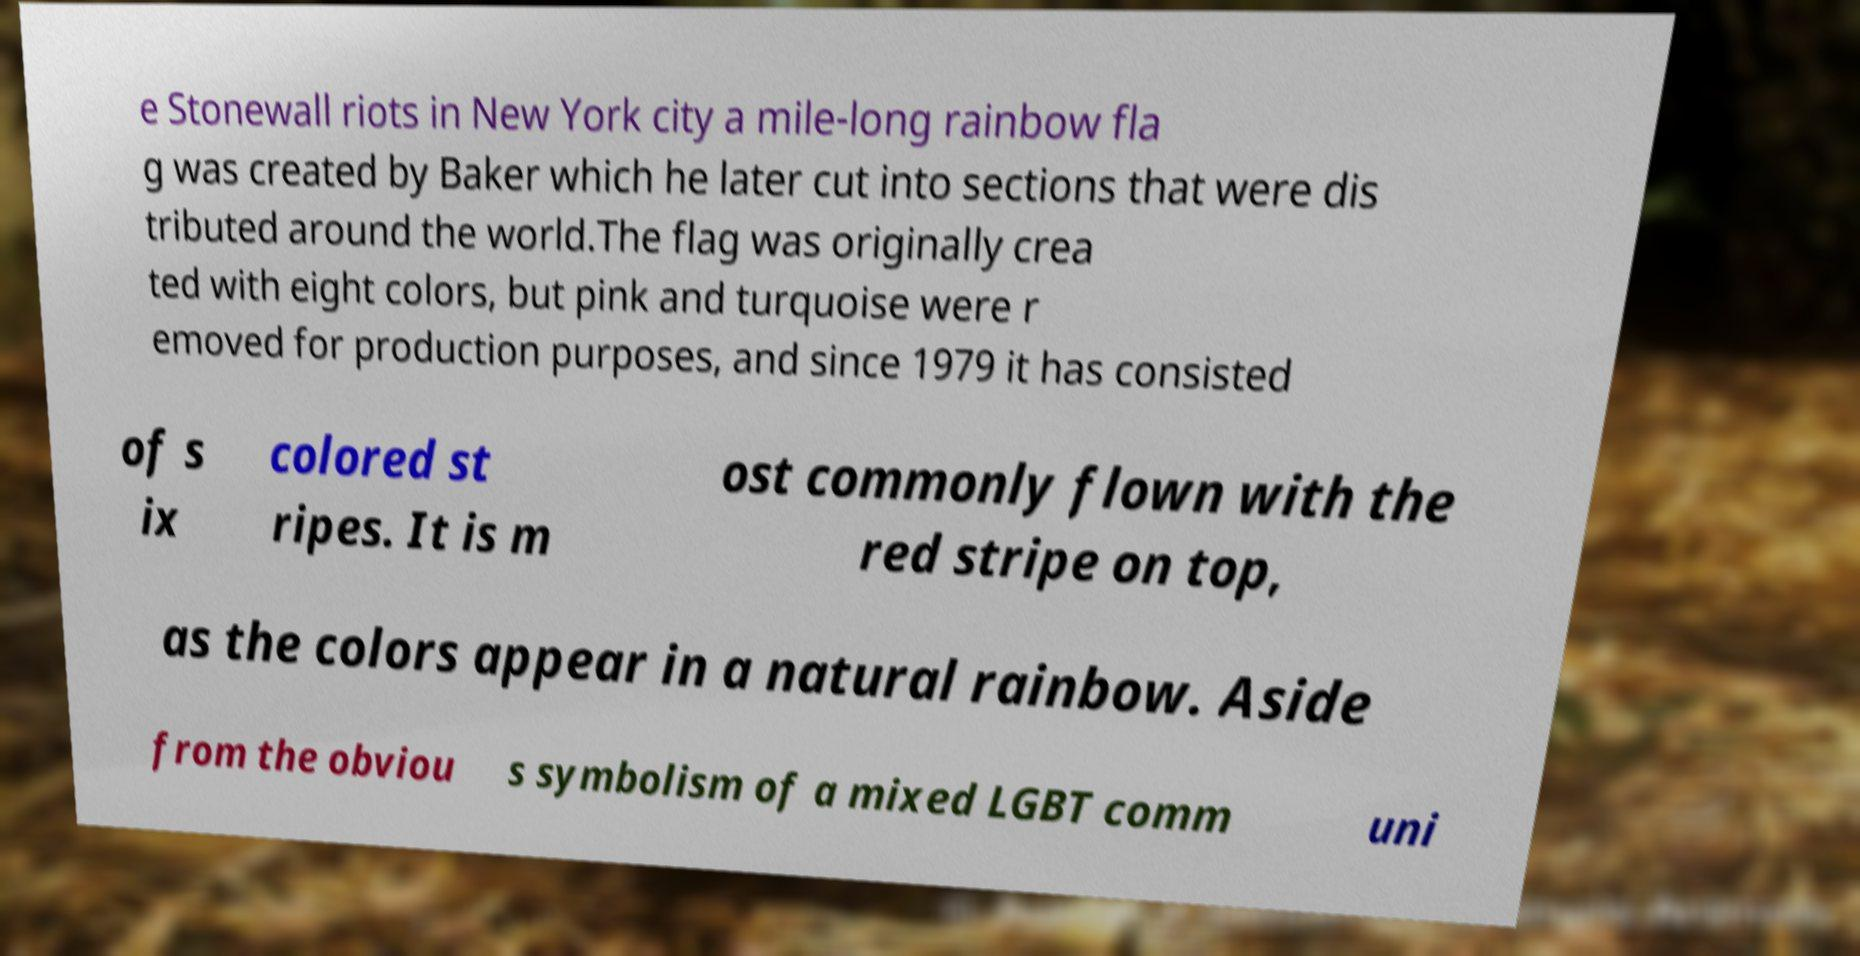There's text embedded in this image that I need extracted. Can you transcribe it verbatim? e Stonewall riots in New York city a mile-long rainbow fla g was created by Baker which he later cut into sections that were dis tributed around the world.The flag was originally crea ted with eight colors, but pink and turquoise were r emoved for production purposes, and since 1979 it has consisted of s ix colored st ripes. It is m ost commonly flown with the red stripe on top, as the colors appear in a natural rainbow. Aside from the obviou s symbolism of a mixed LGBT comm uni 